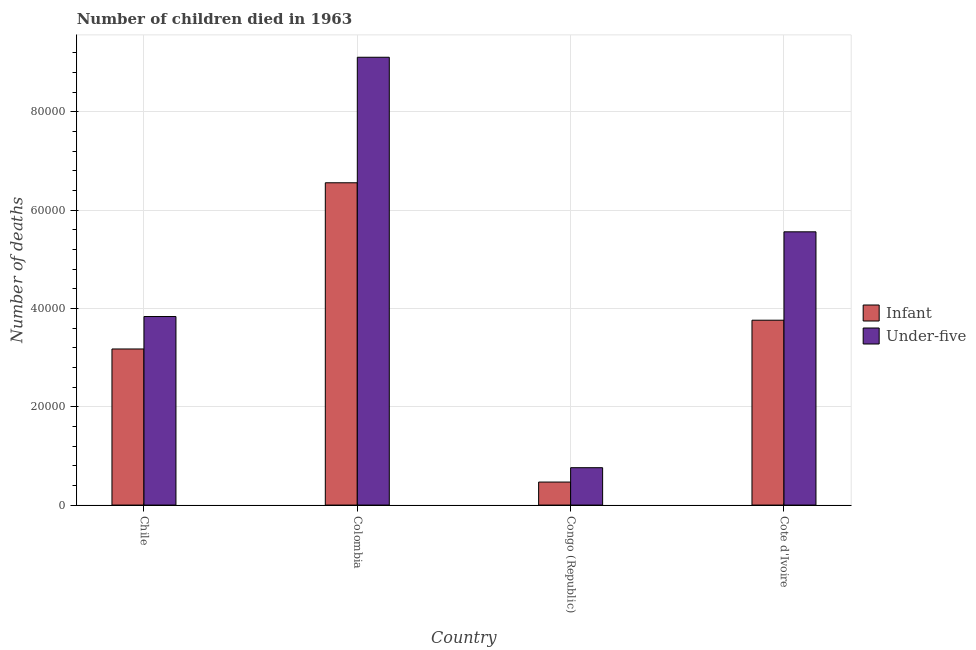How many different coloured bars are there?
Your response must be concise. 2. Are the number of bars on each tick of the X-axis equal?
Provide a short and direct response. Yes. How many bars are there on the 2nd tick from the left?
Provide a short and direct response. 2. What is the number of under-five deaths in Cote d'Ivoire?
Provide a succinct answer. 5.56e+04. Across all countries, what is the maximum number of under-five deaths?
Make the answer very short. 9.11e+04. Across all countries, what is the minimum number of infant deaths?
Provide a succinct answer. 4682. In which country was the number of infant deaths minimum?
Give a very brief answer. Congo (Republic). What is the total number of under-five deaths in the graph?
Your response must be concise. 1.93e+05. What is the difference between the number of infant deaths in Colombia and that in Congo (Republic)?
Keep it short and to the point. 6.09e+04. What is the difference between the number of infant deaths in Colombia and the number of under-five deaths in Cote d'Ivoire?
Your answer should be compact. 9980. What is the average number of under-five deaths per country?
Your answer should be very brief. 4.82e+04. What is the difference between the number of infant deaths and number of under-five deaths in Cote d'Ivoire?
Your answer should be compact. -1.80e+04. What is the ratio of the number of under-five deaths in Colombia to that in Congo (Republic)?
Offer a terse response. 11.98. Is the number of infant deaths in Chile less than that in Congo (Republic)?
Ensure brevity in your answer.  No. Is the difference between the number of infant deaths in Chile and Cote d'Ivoire greater than the difference between the number of under-five deaths in Chile and Cote d'Ivoire?
Make the answer very short. Yes. What is the difference between the highest and the second highest number of under-five deaths?
Offer a terse response. 3.55e+04. What is the difference between the highest and the lowest number of under-five deaths?
Make the answer very short. 8.35e+04. What does the 1st bar from the left in Cote d'Ivoire represents?
Make the answer very short. Infant. What does the 2nd bar from the right in Cote d'Ivoire represents?
Make the answer very short. Infant. Are all the bars in the graph horizontal?
Your answer should be compact. No. What is the difference between two consecutive major ticks on the Y-axis?
Make the answer very short. 2.00e+04. Are the values on the major ticks of Y-axis written in scientific E-notation?
Give a very brief answer. No. How many legend labels are there?
Offer a very short reply. 2. What is the title of the graph?
Your answer should be very brief. Number of children died in 1963. Does "Net savings(excluding particulate emission damage)" appear as one of the legend labels in the graph?
Ensure brevity in your answer.  No. What is the label or title of the Y-axis?
Provide a short and direct response. Number of deaths. What is the Number of deaths in Infant in Chile?
Offer a terse response. 3.18e+04. What is the Number of deaths of Under-five in Chile?
Provide a short and direct response. 3.84e+04. What is the Number of deaths in Infant in Colombia?
Make the answer very short. 6.56e+04. What is the Number of deaths in Under-five in Colombia?
Ensure brevity in your answer.  9.11e+04. What is the Number of deaths of Infant in Congo (Republic)?
Your answer should be very brief. 4682. What is the Number of deaths of Under-five in Congo (Republic)?
Your answer should be very brief. 7604. What is the Number of deaths in Infant in Cote d'Ivoire?
Ensure brevity in your answer.  3.76e+04. What is the Number of deaths of Under-five in Cote d'Ivoire?
Give a very brief answer. 5.56e+04. Across all countries, what is the maximum Number of deaths of Infant?
Keep it short and to the point. 6.56e+04. Across all countries, what is the maximum Number of deaths of Under-five?
Ensure brevity in your answer.  9.11e+04. Across all countries, what is the minimum Number of deaths in Infant?
Your response must be concise. 4682. Across all countries, what is the minimum Number of deaths of Under-five?
Provide a succinct answer. 7604. What is the total Number of deaths of Infant in the graph?
Your answer should be compact. 1.40e+05. What is the total Number of deaths of Under-five in the graph?
Your response must be concise. 1.93e+05. What is the difference between the Number of deaths in Infant in Chile and that in Colombia?
Provide a short and direct response. -3.38e+04. What is the difference between the Number of deaths in Under-five in Chile and that in Colombia?
Your answer should be compact. -5.27e+04. What is the difference between the Number of deaths in Infant in Chile and that in Congo (Republic)?
Ensure brevity in your answer.  2.71e+04. What is the difference between the Number of deaths of Under-five in Chile and that in Congo (Republic)?
Provide a short and direct response. 3.08e+04. What is the difference between the Number of deaths of Infant in Chile and that in Cote d'Ivoire?
Your answer should be very brief. -5852. What is the difference between the Number of deaths in Under-five in Chile and that in Cote d'Ivoire?
Provide a short and direct response. -1.72e+04. What is the difference between the Number of deaths of Infant in Colombia and that in Congo (Republic)?
Provide a succinct answer. 6.09e+04. What is the difference between the Number of deaths of Under-five in Colombia and that in Congo (Republic)?
Provide a short and direct response. 8.35e+04. What is the difference between the Number of deaths of Infant in Colombia and that in Cote d'Ivoire?
Make the answer very short. 2.80e+04. What is the difference between the Number of deaths in Under-five in Colombia and that in Cote d'Ivoire?
Make the answer very short. 3.55e+04. What is the difference between the Number of deaths of Infant in Congo (Republic) and that in Cote d'Ivoire?
Give a very brief answer. -3.29e+04. What is the difference between the Number of deaths in Under-five in Congo (Republic) and that in Cote d'Ivoire?
Give a very brief answer. -4.80e+04. What is the difference between the Number of deaths in Infant in Chile and the Number of deaths in Under-five in Colombia?
Your response must be concise. -5.94e+04. What is the difference between the Number of deaths in Infant in Chile and the Number of deaths in Under-five in Congo (Republic)?
Your answer should be very brief. 2.42e+04. What is the difference between the Number of deaths in Infant in Chile and the Number of deaths in Under-five in Cote d'Ivoire?
Your answer should be very brief. -2.38e+04. What is the difference between the Number of deaths of Infant in Colombia and the Number of deaths of Under-five in Congo (Republic)?
Provide a short and direct response. 5.80e+04. What is the difference between the Number of deaths of Infant in Colombia and the Number of deaths of Under-five in Cote d'Ivoire?
Offer a very short reply. 9980. What is the difference between the Number of deaths of Infant in Congo (Republic) and the Number of deaths of Under-five in Cote d'Ivoire?
Offer a terse response. -5.09e+04. What is the average Number of deaths in Infant per country?
Give a very brief answer. 3.49e+04. What is the average Number of deaths in Under-five per country?
Offer a very short reply. 4.82e+04. What is the difference between the Number of deaths in Infant and Number of deaths in Under-five in Chile?
Offer a terse response. -6602. What is the difference between the Number of deaths in Infant and Number of deaths in Under-five in Colombia?
Provide a short and direct response. -2.55e+04. What is the difference between the Number of deaths in Infant and Number of deaths in Under-five in Congo (Republic)?
Your response must be concise. -2922. What is the difference between the Number of deaths of Infant and Number of deaths of Under-five in Cote d'Ivoire?
Provide a succinct answer. -1.80e+04. What is the ratio of the Number of deaths in Infant in Chile to that in Colombia?
Ensure brevity in your answer.  0.48. What is the ratio of the Number of deaths of Under-five in Chile to that in Colombia?
Your answer should be compact. 0.42. What is the ratio of the Number of deaths of Infant in Chile to that in Congo (Republic)?
Your answer should be compact. 6.78. What is the ratio of the Number of deaths in Under-five in Chile to that in Congo (Republic)?
Your response must be concise. 5.04. What is the ratio of the Number of deaths of Infant in Chile to that in Cote d'Ivoire?
Ensure brevity in your answer.  0.84. What is the ratio of the Number of deaths in Under-five in Chile to that in Cote d'Ivoire?
Make the answer very short. 0.69. What is the ratio of the Number of deaths of Infant in Colombia to that in Congo (Republic)?
Ensure brevity in your answer.  14.01. What is the ratio of the Number of deaths in Under-five in Colombia to that in Congo (Republic)?
Provide a short and direct response. 11.98. What is the ratio of the Number of deaths in Infant in Colombia to that in Cote d'Ivoire?
Provide a succinct answer. 1.74. What is the ratio of the Number of deaths of Under-five in Colombia to that in Cote d'Ivoire?
Your answer should be very brief. 1.64. What is the ratio of the Number of deaths in Infant in Congo (Republic) to that in Cote d'Ivoire?
Provide a short and direct response. 0.12. What is the ratio of the Number of deaths in Under-five in Congo (Republic) to that in Cote d'Ivoire?
Your answer should be very brief. 0.14. What is the difference between the highest and the second highest Number of deaths of Infant?
Your response must be concise. 2.80e+04. What is the difference between the highest and the second highest Number of deaths of Under-five?
Offer a terse response. 3.55e+04. What is the difference between the highest and the lowest Number of deaths of Infant?
Provide a short and direct response. 6.09e+04. What is the difference between the highest and the lowest Number of deaths of Under-five?
Your response must be concise. 8.35e+04. 